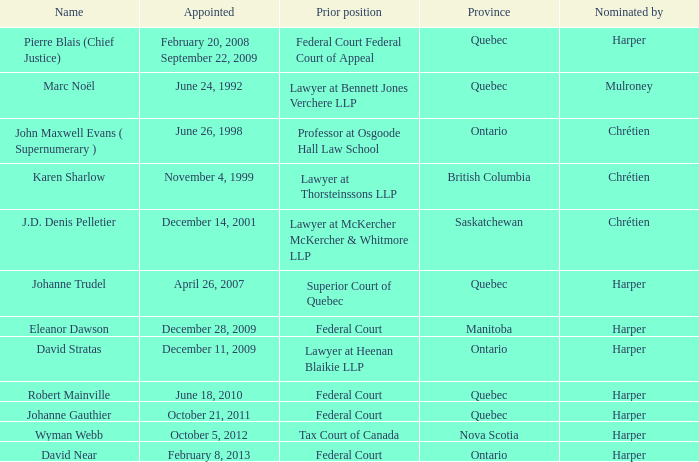What was the previous role occupied by wyman webb? Tax Court of Canada. 